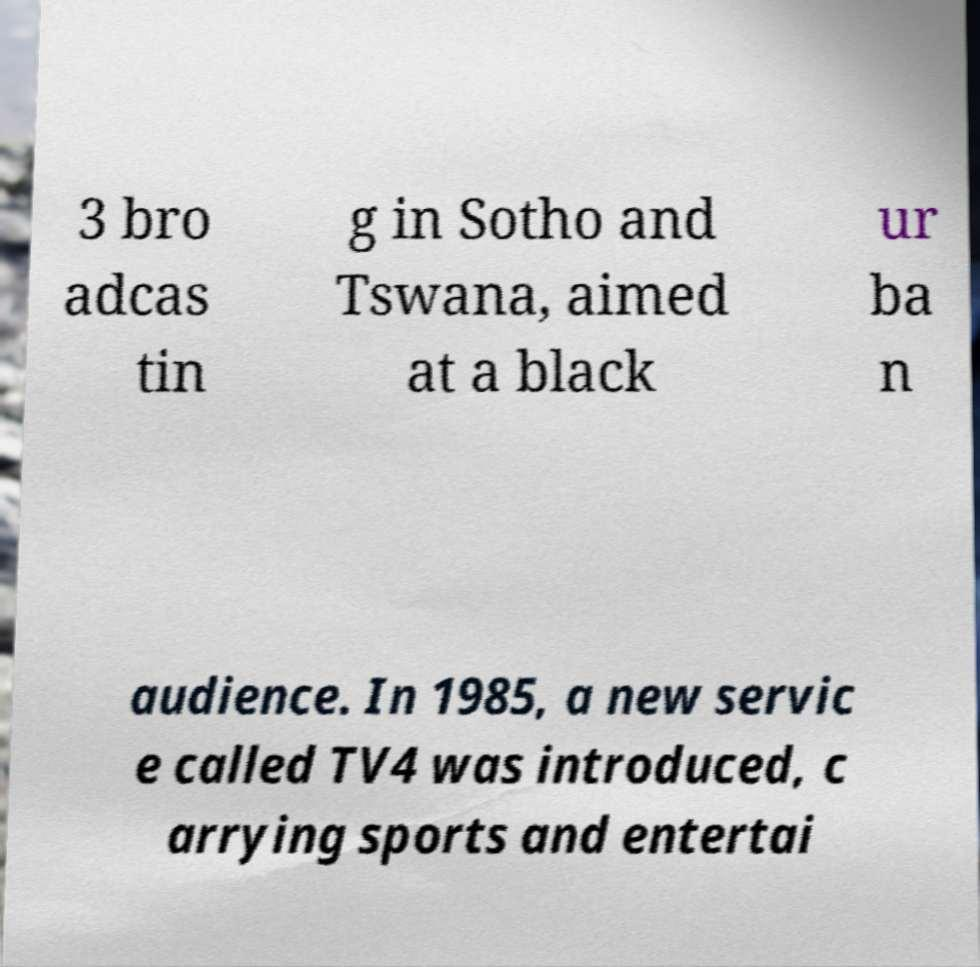Can you read and provide the text displayed in the image?This photo seems to have some interesting text. Can you extract and type it out for me? 3 bro adcas tin g in Sotho and Tswana, aimed at a black ur ba n audience. In 1985, a new servic e called TV4 was introduced, c arrying sports and entertai 